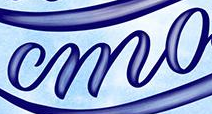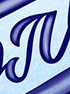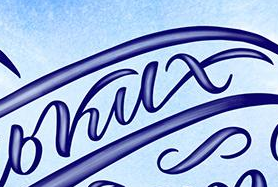What text is displayed in these images sequentially, separated by a semicolon? mo; #; bkux 